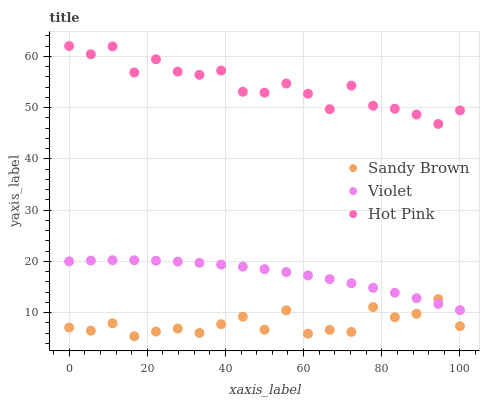Does Sandy Brown have the minimum area under the curve?
Answer yes or no. Yes. Does Hot Pink have the maximum area under the curve?
Answer yes or no. Yes. Does Violet have the minimum area under the curve?
Answer yes or no. No. Does Violet have the maximum area under the curve?
Answer yes or no. No. Is Violet the smoothest?
Answer yes or no. Yes. Is Hot Pink the roughest?
Answer yes or no. Yes. Is Sandy Brown the smoothest?
Answer yes or no. No. Is Sandy Brown the roughest?
Answer yes or no. No. Does Sandy Brown have the lowest value?
Answer yes or no. Yes. Does Violet have the lowest value?
Answer yes or no. No. Does Hot Pink have the highest value?
Answer yes or no. Yes. Does Violet have the highest value?
Answer yes or no. No. Is Sandy Brown less than Hot Pink?
Answer yes or no. Yes. Is Hot Pink greater than Violet?
Answer yes or no. Yes. Does Sandy Brown intersect Violet?
Answer yes or no. Yes. Is Sandy Brown less than Violet?
Answer yes or no. No. Is Sandy Brown greater than Violet?
Answer yes or no. No. Does Sandy Brown intersect Hot Pink?
Answer yes or no. No. 